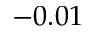<formula> <loc_0><loc_0><loc_500><loc_500>- 0 . 0 1</formula> 